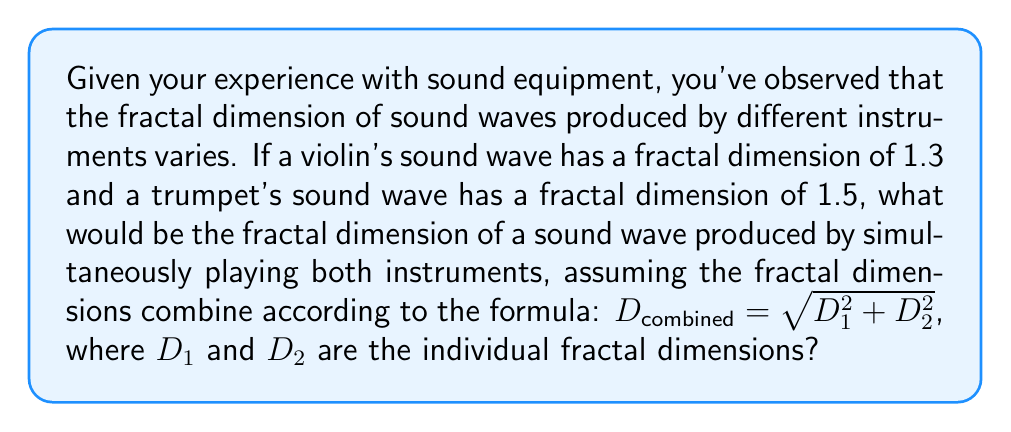Provide a solution to this math problem. To solve this problem, we'll use the given formula for combining fractal dimensions:

$$D_{combined} = \sqrt{D_1^2 + D_2^2}$$

Where:
$D_1 = 1.3$ (fractal dimension of violin's sound wave)
$D_2 = 1.5$ (fractal dimension of trumpet's sound wave)

Let's substitute these values into the formula:

$$D_{combined} = \sqrt{1.3^2 + 1.5^2}$$

Now, let's calculate step by step:

1. Calculate $1.3^2$:
   $1.3^2 = 1.69$

2. Calculate $1.5^2$:
   $1.5^2 = 2.25$

3. Add the results from steps 1 and 2:
   $1.69 + 2.25 = 3.94$

4. Take the square root of the sum:
   $\sqrt{3.94} \approx 1.9849$

Therefore, the fractal dimension of the combined sound wave is approximately 1.9849.
Answer: 1.9849 